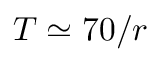<formula> <loc_0><loc_0><loc_500><loc_500>T \simeq 7 0 / r</formula> 